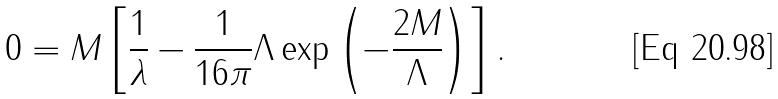Convert formula to latex. <formula><loc_0><loc_0><loc_500><loc_500>0 = M \left [ \frac { 1 } { \lambda } - \frac { 1 } { 1 6 \pi } \Lambda \exp \left ( - \frac { 2 M } { \Lambda } \right ) \right ] .</formula> 